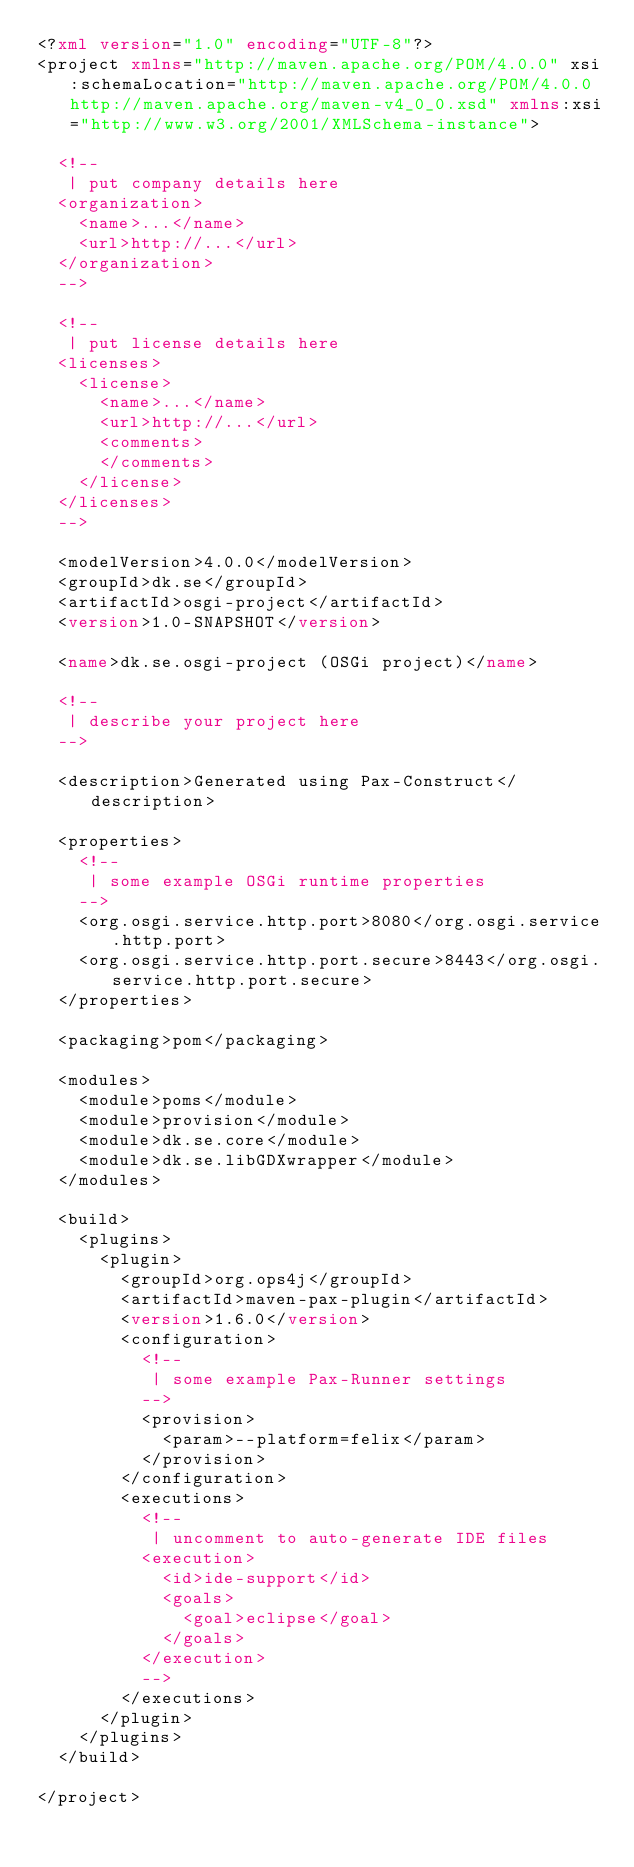Convert code to text. <code><loc_0><loc_0><loc_500><loc_500><_XML_><?xml version="1.0" encoding="UTF-8"?>
<project xmlns="http://maven.apache.org/POM/4.0.0" xsi:schemaLocation="http://maven.apache.org/POM/4.0.0 http://maven.apache.org/maven-v4_0_0.xsd" xmlns:xsi="http://www.w3.org/2001/XMLSchema-instance">

  <!--
   | put company details here
  <organization>
    <name>...</name>
    <url>http://...</url>
  </organization>
  -->

  <!--
   | put license details here
  <licenses>
    <license>
      <name>...</name>
      <url>http://...</url>
      <comments>
      </comments>
    </license>
  </licenses>
  -->

  <modelVersion>4.0.0</modelVersion>
  <groupId>dk.se</groupId>
  <artifactId>osgi-project</artifactId>
  <version>1.0-SNAPSHOT</version>

  <name>dk.se.osgi-project (OSGi project)</name>

  <!--
   | describe your project here
  -->

  <description>Generated using Pax-Construct</description>

  <properties>
    <!--
     | some example OSGi runtime properties
    -->
    <org.osgi.service.http.port>8080</org.osgi.service.http.port>
    <org.osgi.service.http.port.secure>8443</org.osgi.service.http.port.secure>
  </properties>

  <packaging>pom</packaging>

  <modules>
    <module>poms</module>
    <module>provision</module>
    <module>dk.se.core</module>
    <module>dk.se.libGDXwrapper</module>
  </modules>

  <build>
    <plugins>
      <plugin>
        <groupId>org.ops4j</groupId>
        <artifactId>maven-pax-plugin</artifactId>
        <version>1.6.0</version>
        <configuration>
          <!--
           | some example Pax-Runner settings
          -->
          <provision>
            <param>--platform=felix</param>
          </provision>
        </configuration>
        <executions>
          <!--
           | uncomment to auto-generate IDE files
          <execution>
            <id>ide-support</id>
            <goals>
              <goal>eclipse</goal>
            </goals>
          </execution>
          -->
        </executions>
      </plugin>
    </plugins>
  </build>

</project></code> 